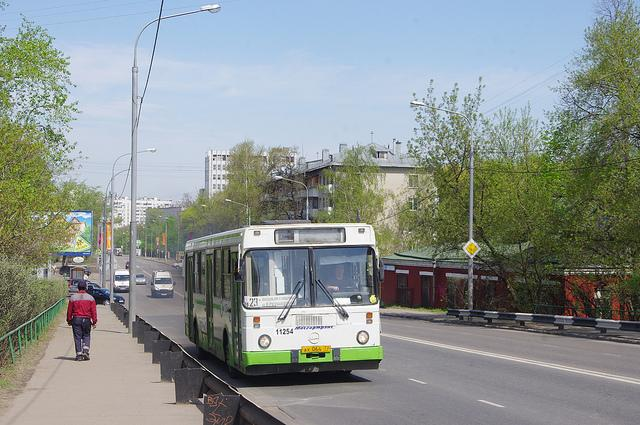Which car is in the greatest danger?

Choices:
A) grey car
B) white bus
C) black car
D) white truck black car 